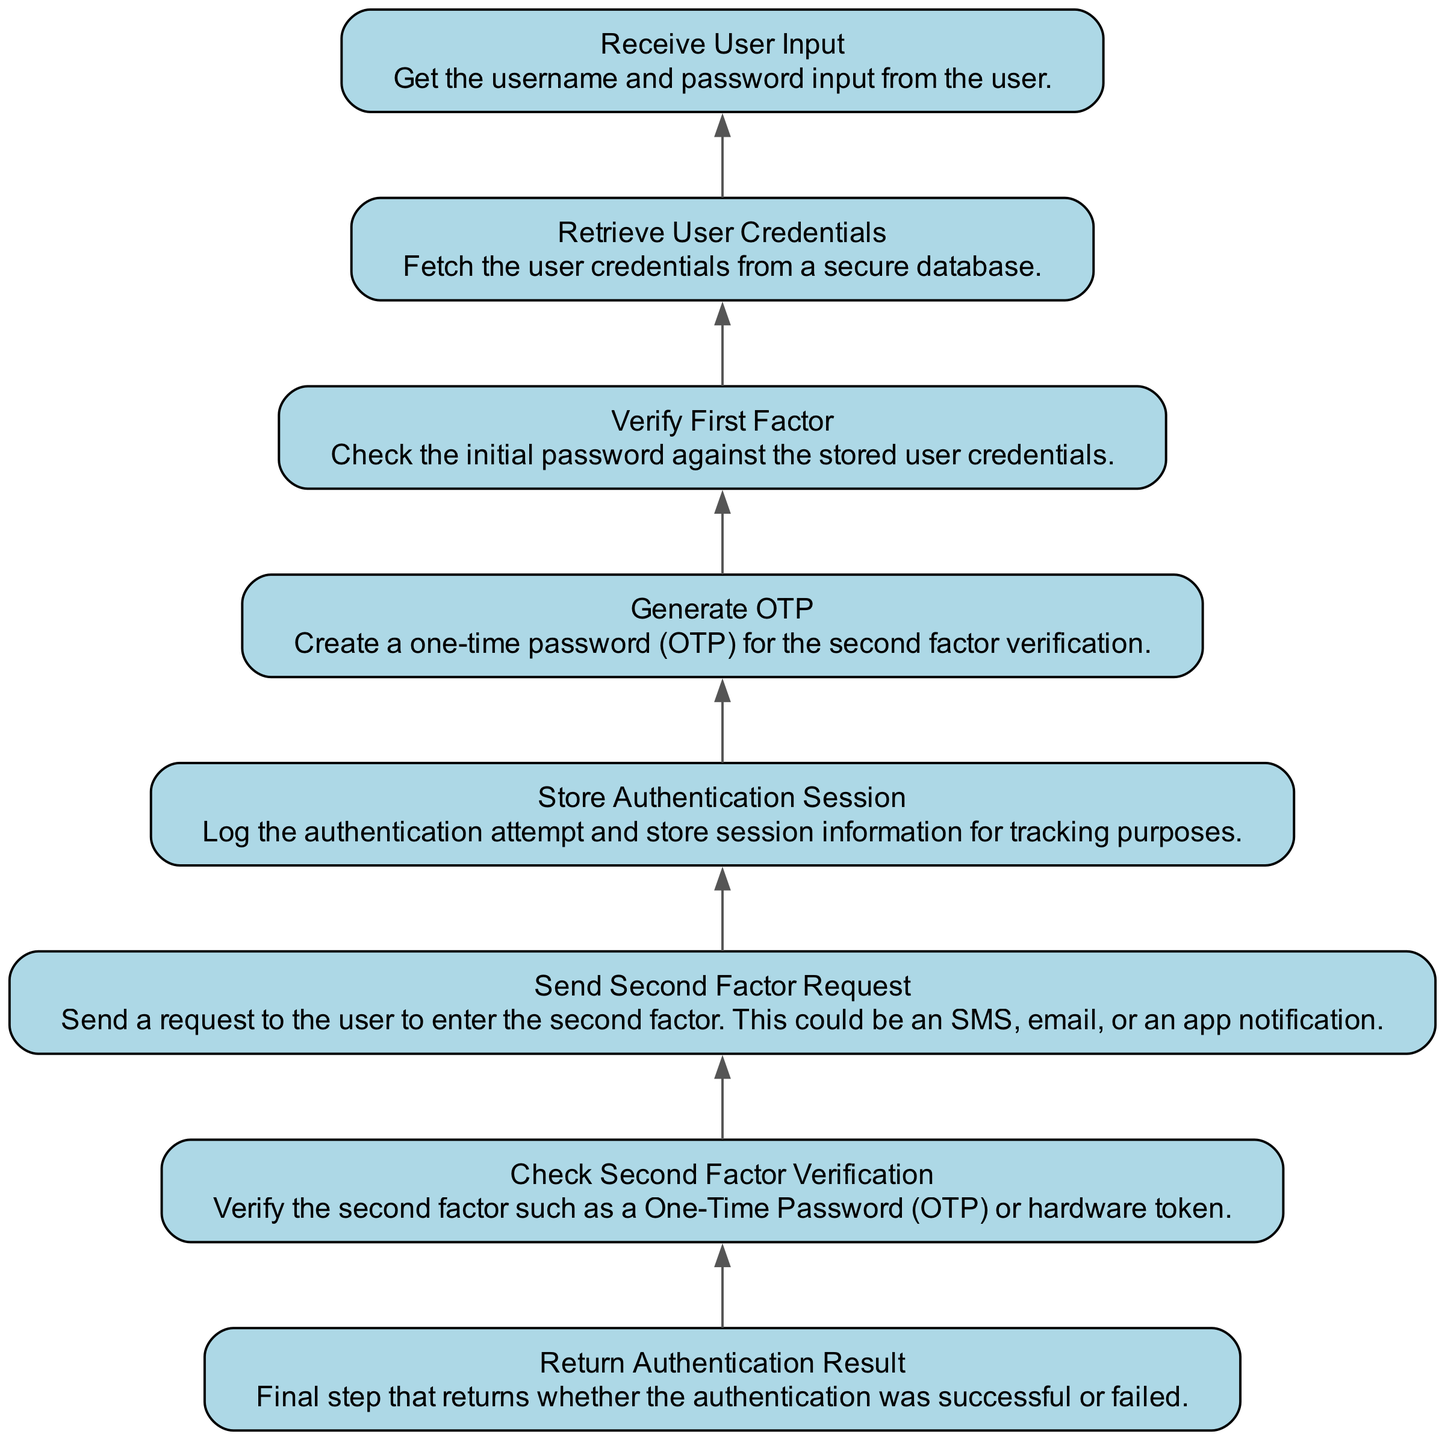What is the first step in the diagram? The first step in the flowchart is represented by the last node, which is "Receive User Input". Since the flow is from bottom to up, this is the starting point of the execution process.
Answer: Receive User Input How many nodes are present in the diagram? The diagram contains a total of 8 nodes, as each step in the Two-Factor Authentication process is represented as a node. Counting all the elements listed confirms this total.
Answer: 8 What does the second node signify in the flow? The second node is "Verify First Factor", which signifies the action of checking the user's initial password against stored credentials. This verification step follows the receipt of user input.
Answer: Verify First Factor What happens after generating the OTP? After generating the OTP, the next step is "Send Second Factor Request", which involves sending a request to the user for entering the OTP as part of the Two-Factor Authentication process.
Answer: Send Second Factor Request What is the final output of the workflow? The final output of the workflow is "Return Authentication Result", which determines the overall success or failure of the Two-Factor Authentication process after all checks are executed.
Answer: Return Authentication Result What action must occur before checking the second factor verification? Before checking the second factor verification, the action "Check Second Factor Verification" must be executed immediately after verifying the first factor, ensuring that all necessary credentials have been validated.
Answer: Verifying the first factor How are user credentials retrieved in the process? User credentials are retrieved through the process indicated by the node "Retrieve User Credentials", which precedes the verification of the first factor and is crucial for authentication.
Answer: Retrieve User Credentials What is the second to last step before returning the authentication result? The second to last step is "Check Second Factor Verification", which is critical before concluding whether the user has been successfully authenticated or not.
Answer: Check Second Factor Verification 